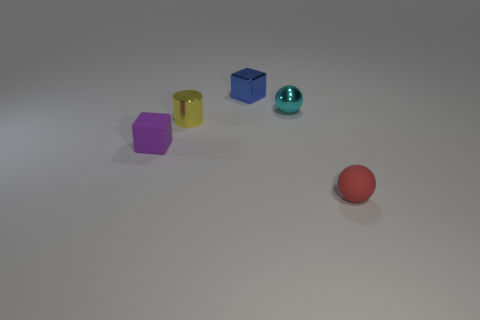What color is the metallic ball that is the same size as the yellow metal thing?
Your answer should be compact. Cyan. Does the purple object have the same size as the block to the right of the purple matte thing?
Your response must be concise. Yes. How many things are tiny purple matte blocks or small cubes that are to the right of the small yellow metal cylinder?
Offer a terse response. 2. There is a block that is on the right side of the yellow thing; is it the same size as the metallic thing in front of the tiny cyan metallic object?
Ensure brevity in your answer.  Yes. Are there any small cylinders that have the same material as the tiny purple cube?
Provide a succinct answer. No. The blue thing has what shape?
Offer a very short reply. Cube. There is a small matte object that is in front of the thing that is on the left side of the tiny yellow metallic cylinder; what is its shape?
Your answer should be compact. Sphere. How many other objects are the same shape as the blue object?
Provide a succinct answer. 1. There is a ball to the right of the tiny metal thing that is right of the small blue object; what size is it?
Give a very brief answer. Small. Is there a large brown matte cylinder?
Make the answer very short. No. 